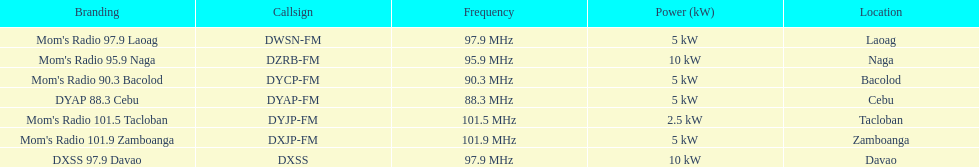What is the number of these stations broadcasting at a frequency of greater than 100 mhz? 2. 